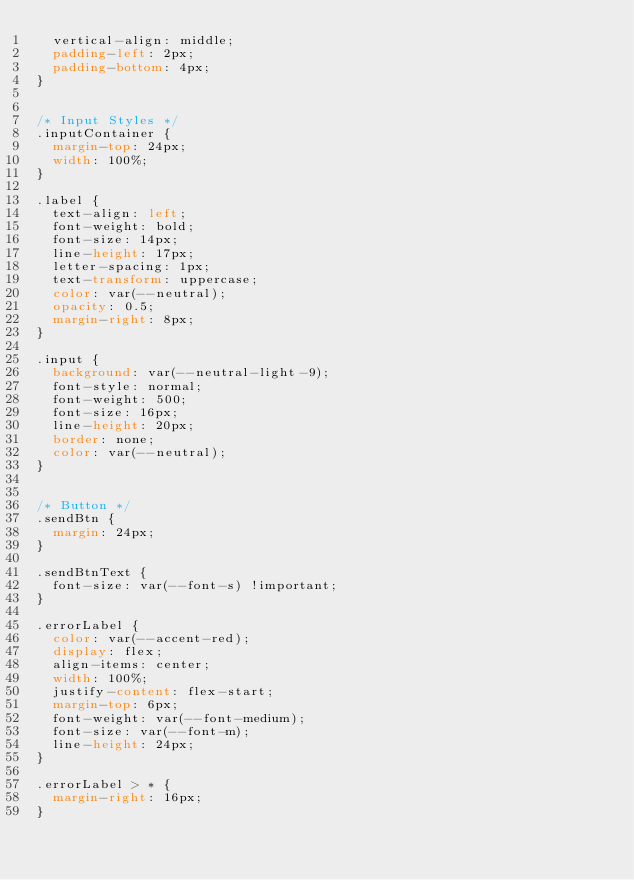<code> <loc_0><loc_0><loc_500><loc_500><_CSS_>  vertical-align: middle;
  padding-left: 2px;
  padding-bottom: 4px;
}


/* Input Styles */
.inputContainer {
  margin-top: 24px;
  width: 100%;
}

.label {
  text-align: left;
  font-weight: bold;
  font-size: 14px;
  line-height: 17px;
  letter-spacing: 1px;
  text-transform: uppercase;
  color: var(--neutral);
  opacity: 0.5;
  margin-right: 8px;
}

.input {
  background: var(--neutral-light-9);
  font-style: normal;
  font-weight: 500;
  font-size: 16px;
  line-height: 20px;
  border: none;
  color: var(--neutral);
}


/* Button */
.sendBtn {
  margin: 24px;
}

.sendBtnText {
  font-size: var(--font-s) !important;
}

.errorLabel {
  color: var(--accent-red);
  display: flex;
  align-items: center;
  width: 100%;
  justify-content: flex-start;
  margin-top: 6px;
  font-weight: var(--font-medium);
  font-size: var(--font-m);
  line-height: 24px;
}

.errorLabel > * {
  margin-right: 16px;
}</code> 